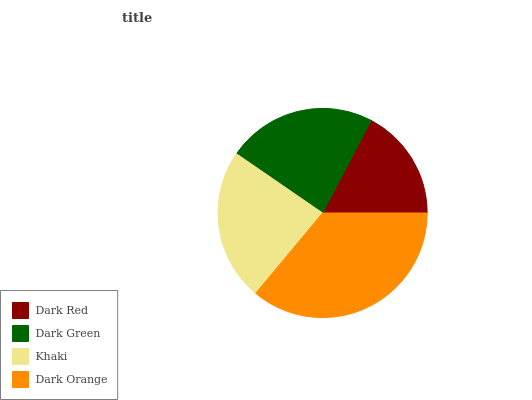Is Dark Red the minimum?
Answer yes or no. Yes. Is Dark Orange the maximum?
Answer yes or no. Yes. Is Dark Green the minimum?
Answer yes or no. No. Is Dark Green the maximum?
Answer yes or no. No. Is Dark Green greater than Dark Red?
Answer yes or no. Yes. Is Dark Red less than Dark Green?
Answer yes or no. Yes. Is Dark Red greater than Dark Green?
Answer yes or no. No. Is Dark Green less than Dark Red?
Answer yes or no. No. Is Khaki the high median?
Answer yes or no. Yes. Is Dark Green the low median?
Answer yes or no. Yes. Is Dark Orange the high median?
Answer yes or no. No. Is Dark Orange the low median?
Answer yes or no. No. 